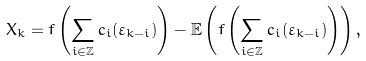<formula> <loc_0><loc_0><loc_500><loc_500>X _ { k } = f \left ( \sum _ { i \in \mathbb { Z } } c _ { i } ( \varepsilon _ { k - i } ) \right ) - \mathbb { E } \left ( f \left ( \sum _ { i \in \mathbb { Z } } c _ { i } ( \varepsilon _ { k - i } ) \right ) \right ) ,</formula> 